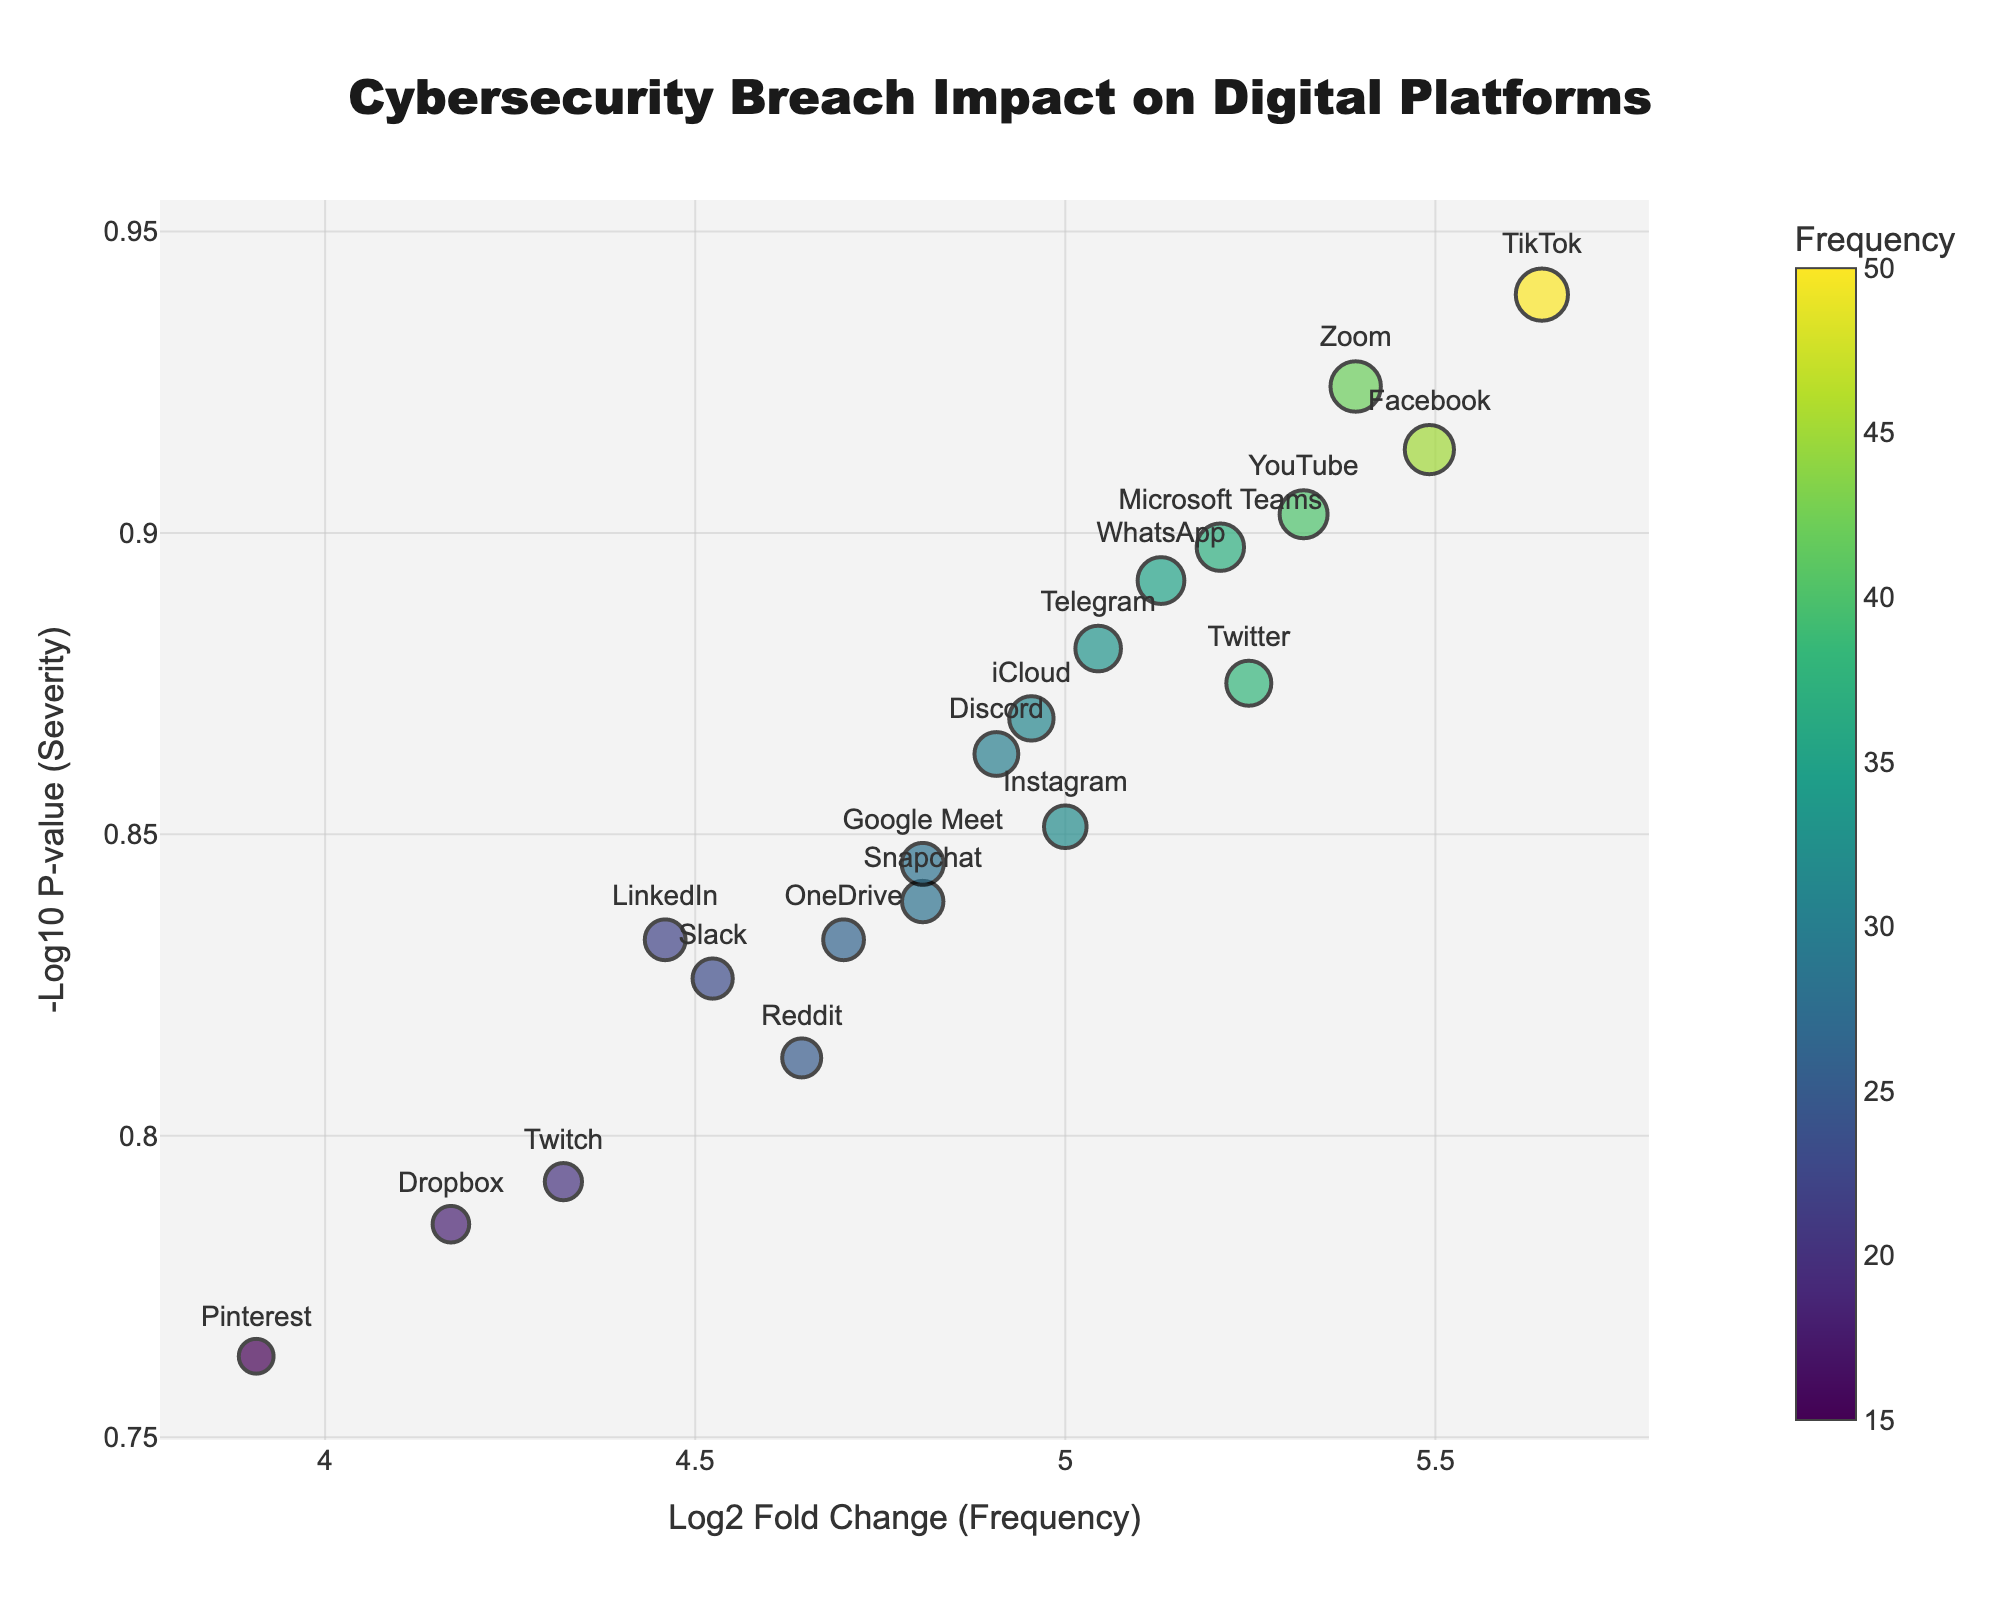What is the title of the plot? The title of the plot is displayed at the top of the figure and centers around the main topic of the plot. Here, it reads "Cybersecurity Breach Impact on Digital Platforms".
Answer: Cybersecurity Breach Impact on Digital Platforms How many digital platforms are represented in the plot? Each digital platform corresponds to a data point marked on the plot. Counting these data points or checking the labels can give the total number of platforms represented.
Answer: 20 Which platform has the highest severity of cybersecurity breaches? The platform with the highest severity will have the largest negative log10 p-value on the y-axis. By observing the plot, TikTok has the highest value on this axis among all platforms.
Answer: TikTok Which platform has the lowest frequency of cybersecurity breaches? The platform with the lowest frequency will have the smallest log2 fold change on the x-axis. Pinterest has the smallest value on this axis.
Answer: Pinterest Which platform has a higher severity: Facebook or Instagram? To determine this, compare the negative log10 p-value (y-axis) of Facebook and Instagram. Facebook has a higher value on the y-axis compared to Instagram.
Answer: Facebook Compare the frequency of breaches between Google Meet and Zoom. Which one experiences more breaches? Look at the log2 fold change (x-axis) for both platforms; Zoom has a higher value compared to Google Meet, indicating more breaches.
Answer: Zoom What color scale represents frequency on the plot? The color of the data points corresponds to the frequency of breaches, with a Viridis color scale being used. This can be seen by the range of colors from light to dark.
Answer: Viridis What's the difference in severity between Snapchat and LinkedIn? Subtract the -log10(p-value) of LinkedIn from that of Snapchat. Both platforms have their respective values marked on the y-axis, and taking the difference of Snapchat’s value (approximately 0.477) and LinkedIn’s value (approximately 0.468) will give the result.
Answer: 0.009 Which platform shows medium severity but high frequency of breaches? A platform with medium severity and high frequency will be located in the middle to upper range on the x-axis and middle on the y-axis. Discord with approximately (4.91, 0.125) fits this description with moderate y-axis value and a significant x-axis value.
Answer: Discord What is the approximate log2 fold change value for YouTube? This value is on the x-axis, where YouTube is plotted. Observing the figure, YouTube has a log2 fold change around 5.32.
Answer: 5.32 